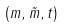Convert formula to latex. <formula><loc_0><loc_0><loc_500><loc_500>( m , \tilde { m } , t )</formula> 